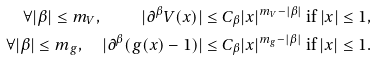Convert formula to latex. <formula><loc_0><loc_0><loc_500><loc_500>\forall | \beta | \leq m _ { V } , \quad | \partial ^ { \beta } V ( x ) | & \leq C _ { \beta } | x | ^ { m _ { V } - | \beta | } \text { if } | x | \leq 1 , \\ \forall | \beta | \leq m _ { g } , \quad | \partial ^ { \beta } ( g ( x ) - 1 ) | & \leq C _ { \beta } | x | ^ { m _ { g } - | \beta | } \text { if } | x | \leq 1 .</formula> 